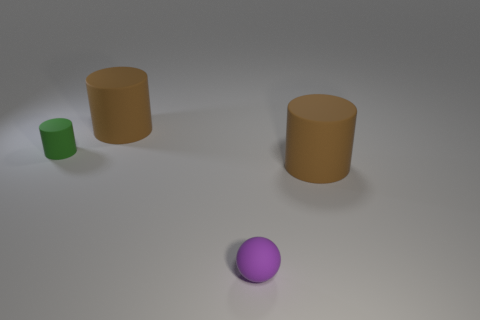What material is the purple thing that is the same size as the green cylinder?
Give a very brief answer. Rubber. What is the color of the large matte object to the left of the brown matte thing in front of the small green cylinder?
Offer a very short reply. Brown. There is a small purple rubber ball; what number of tiny rubber cylinders are behind it?
Give a very brief answer. 1. What is the color of the rubber ball?
Your response must be concise. Purple. What number of tiny things are brown rubber objects or purple matte things?
Provide a succinct answer. 1. There is a cylinder behind the green object; does it have the same color as the rubber cylinder that is on the right side of the purple sphere?
Keep it short and to the point. Yes. How many other objects are the same color as the small cylinder?
Make the answer very short. 0. What is the shape of the large matte object in front of the green matte cylinder?
Make the answer very short. Cylinder. Is the number of small gray rubber spheres less than the number of large matte things?
Your response must be concise. Yes. Are the small purple thing right of the tiny green rubber cylinder and the green cylinder made of the same material?
Offer a terse response. Yes. 